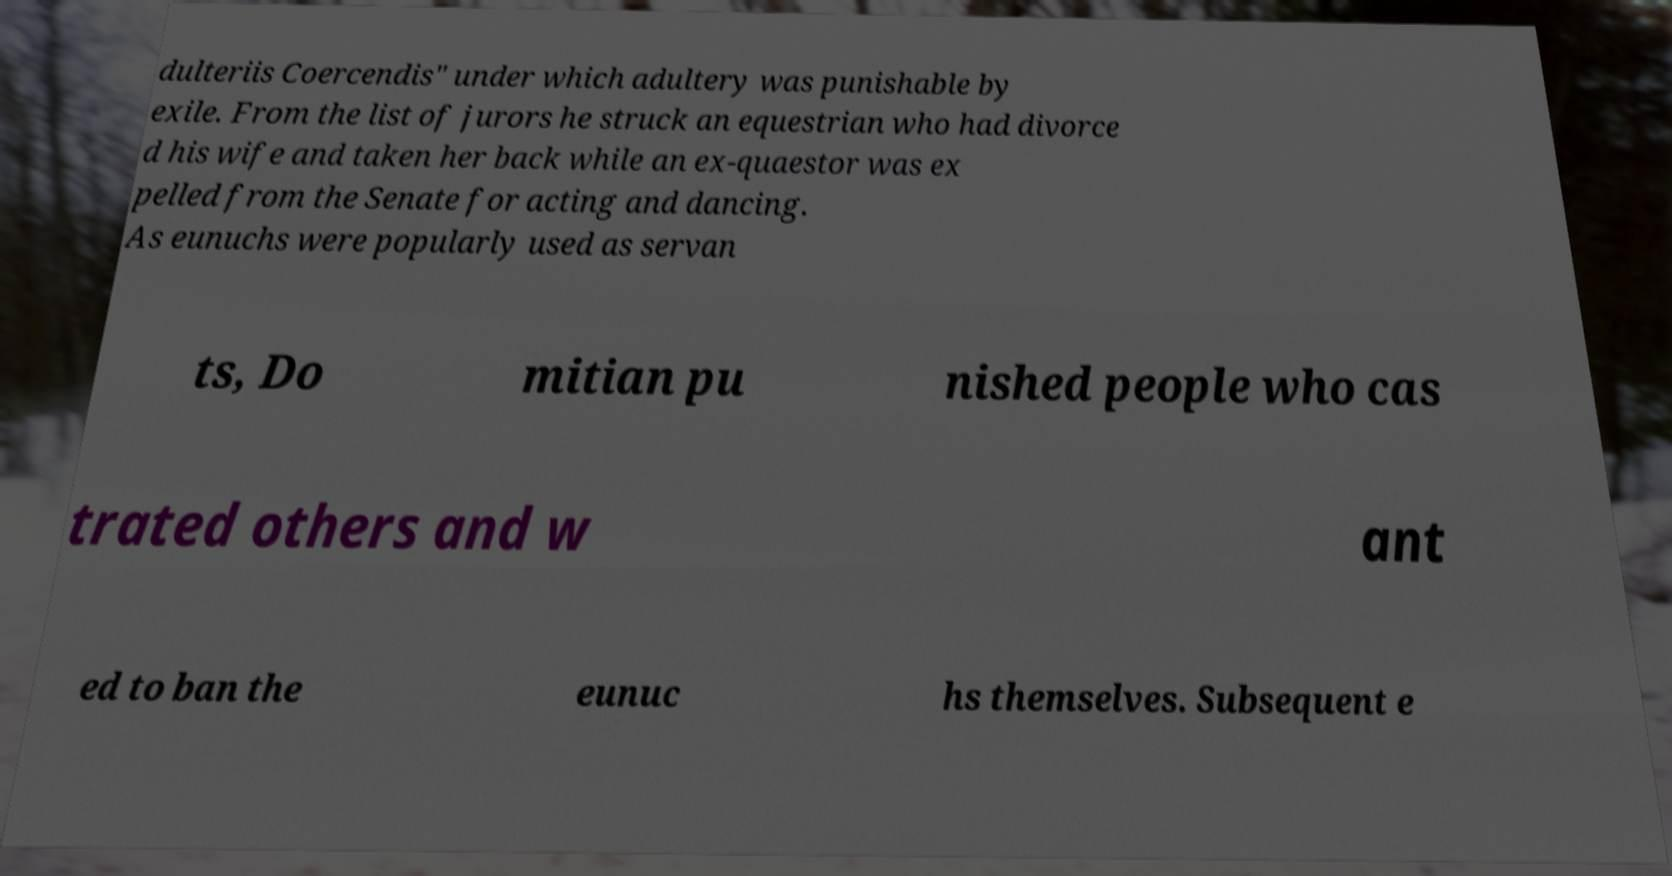Please identify and transcribe the text found in this image. dulteriis Coercendis" under which adultery was punishable by exile. From the list of jurors he struck an equestrian who had divorce d his wife and taken her back while an ex-quaestor was ex pelled from the Senate for acting and dancing. As eunuchs were popularly used as servan ts, Do mitian pu nished people who cas trated others and w ant ed to ban the eunuc hs themselves. Subsequent e 